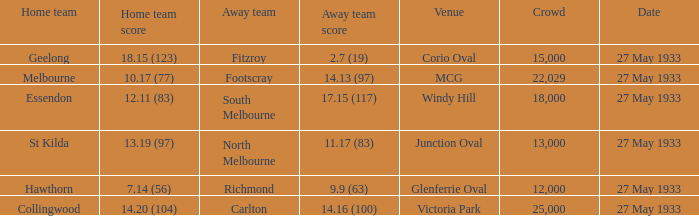How many people were in attendance when the home team scored 14.20 (104) in the match? 25000.0. 